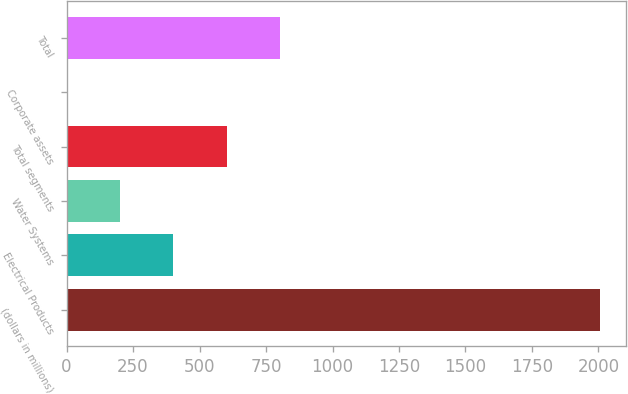<chart> <loc_0><loc_0><loc_500><loc_500><bar_chart><fcel>(dollars in millions)<fcel>Electrical Products<fcel>Water Systems<fcel>Total segments<fcel>Corporate assets<fcel>Total<nl><fcel>2004<fcel>401.36<fcel>201.03<fcel>601.69<fcel>0.7<fcel>802.02<nl></chart> 